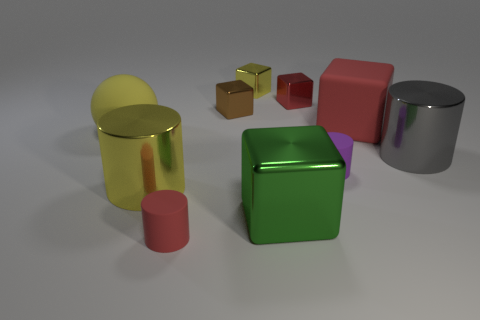Subtract all blue blocks. Subtract all blue spheres. How many blocks are left? 5 Subtract all balls. How many objects are left? 9 Subtract all shiny cylinders. Subtract all tiny shiny blocks. How many objects are left? 5 Add 4 large metallic cylinders. How many large metallic cylinders are left? 6 Add 1 small yellow metal cylinders. How many small yellow metal cylinders exist? 1 Subtract 0 gray blocks. How many objects are left? 10 